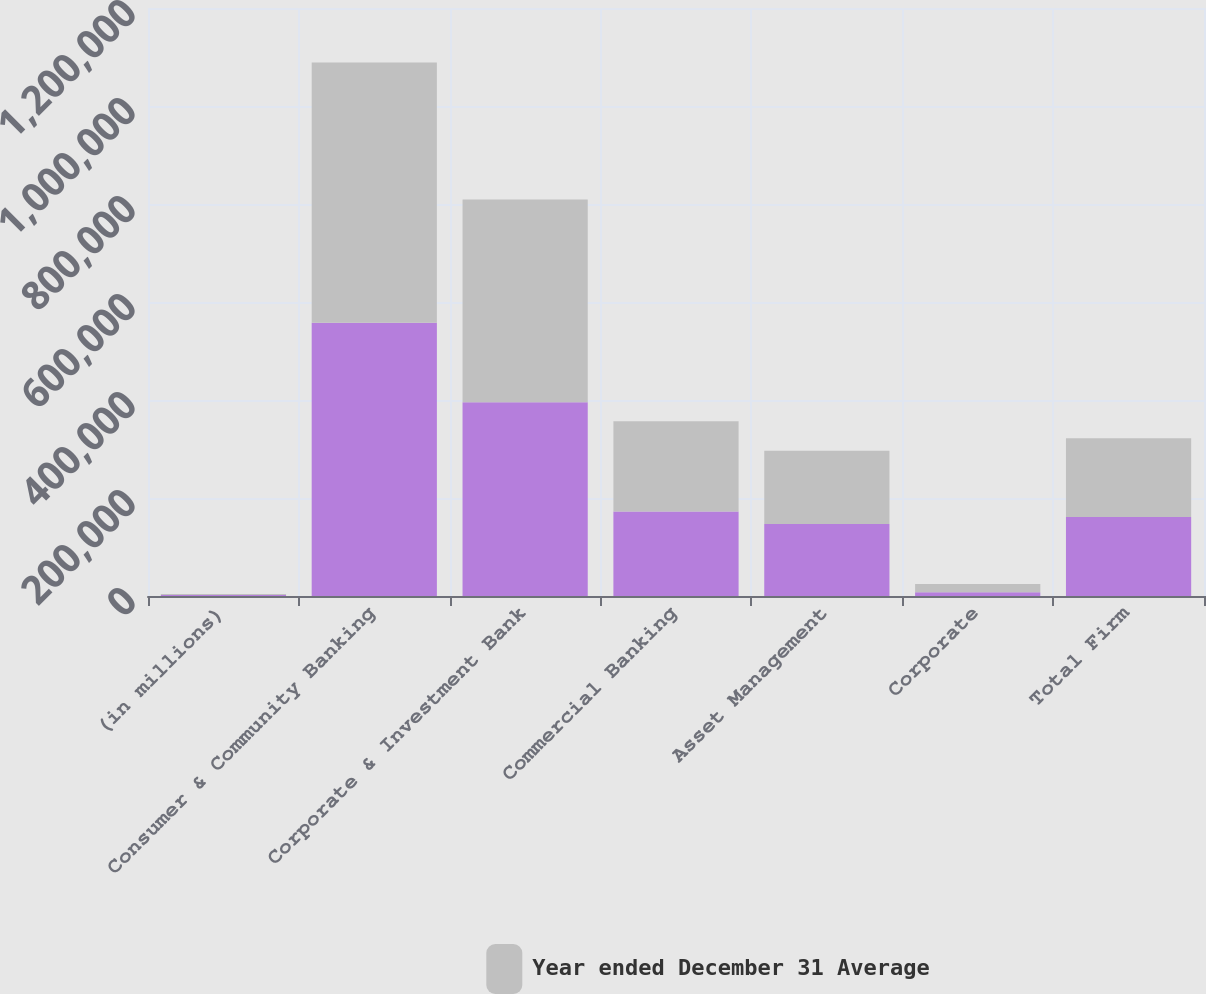<chart> <loc_0><loc_0><loc_500><loc_500><stacked_bar_chart><ecel><fcel>(in millions)<fcel>Consumer & Community Banking<fcel>Corporate & Investment Bank<fcel>Commercial Banking<fcel>Asset Management<fcel>Corporate<fcel>Total Firm<nl><fcel>nan<fcel>2015<fcel>557645<fcel>395228<fcel>172470<fcel>146766<fcel>7606<fcel>160998<nl><fcel>Year ended December 31 Average<fcel>2015<fcel>530938<fcel>414064<fcel>184132<fcel>149525<fcel>17129<fcel>160998<nl></chart> 